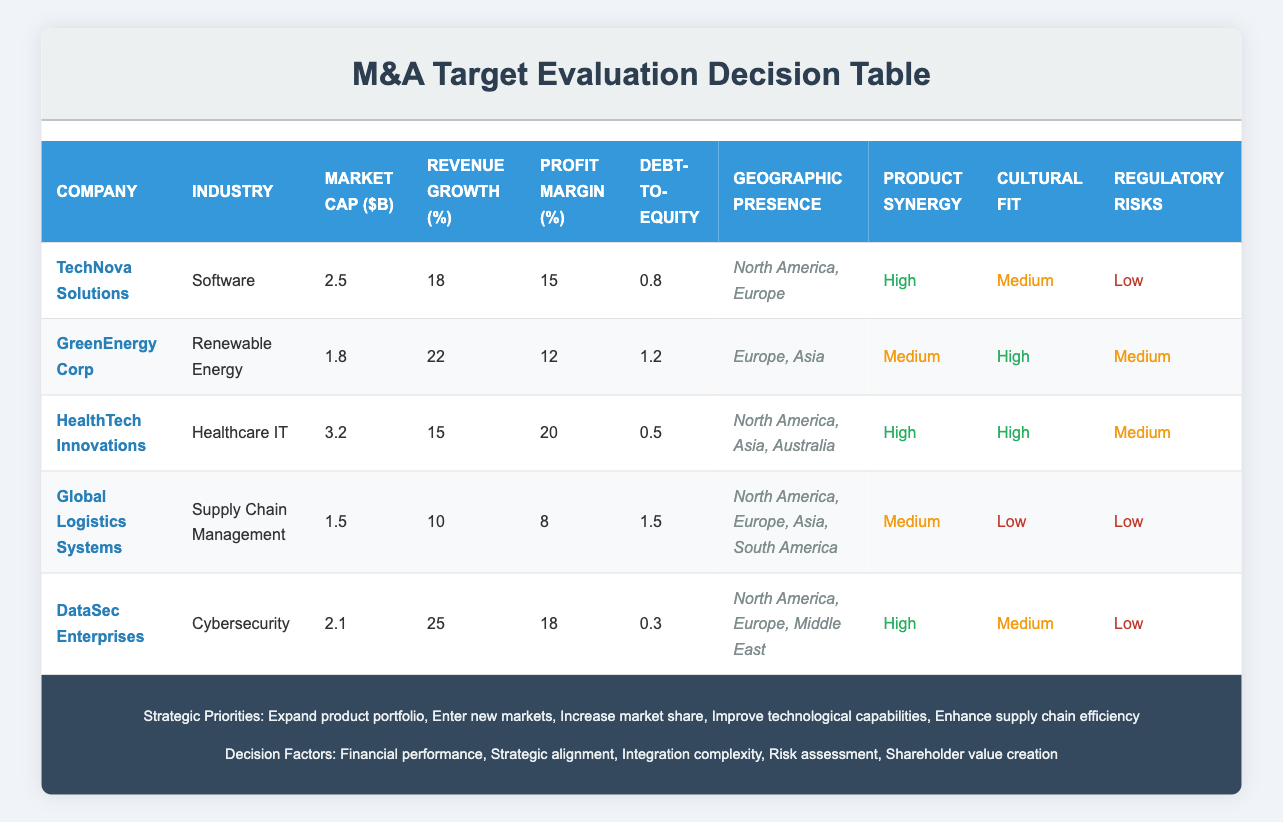What is the market capitalization of HealthTech Innovations? The table shows that HealthTech Innovations has a market cap of 3.2 billion USD.
Answer: 3.2 billion USD Which company has the highest revenue growth rate and what is that rate? By reviewing the table, we see that DataSec Enterprises has the highest revenue growth rate at 25%.
Answer: DataSec Enterprises, 25% Is Global Logistics Systems' profit margin below 10%? The profit margin for Global Logistics Systems is 8%, which is indeed below 10%.
Answer: Yes How many companies have a high cultural fit? Looking at the table, HealthTech Innovations and GreenEnergy Corp both have a high cultural fit, so there are two such companies.
Answer: 2 What is the average debt-to-equity ratio of all the companies listed? The debt-to-equity ratios are: 0.8, 1.2, 0.5, 1.5, and 0.3. Adding these gives 4.3, and then dividing by 5 results in an average of 0.86.
Answer: 0.86 Which company has medium product synergy but high cultural fit? The table shows that GreenEnergy Corp has a medium product synergy and also a high cultural fit.
Answer: GreenEnergy Corp Is there any company with a low regulatory risk that also has a debt-to-equity ratio above 1? Both Global Logistics Systems and GreenEnergy Corp have low regulatory risks, but only Global Logistics Systems has a debt-to-equity ratio of 1.5, which is above 1.
Answer: Yes What is the total market capitalization of all companies in the renewable energy sector? There is only one company in the renewable energy sector, which is GreenEnergy Corp with a market cap of 1.8 billion USD.
Answer: 1.8 billion USD Which companies have a geographic presence in North America? The companies listed with a geographic presence in North America are TechNova Solutions, HealthTech Innovations, DataSec Enterprises, and Global Logistics Systems. That makes four companies.
Answer: 4 